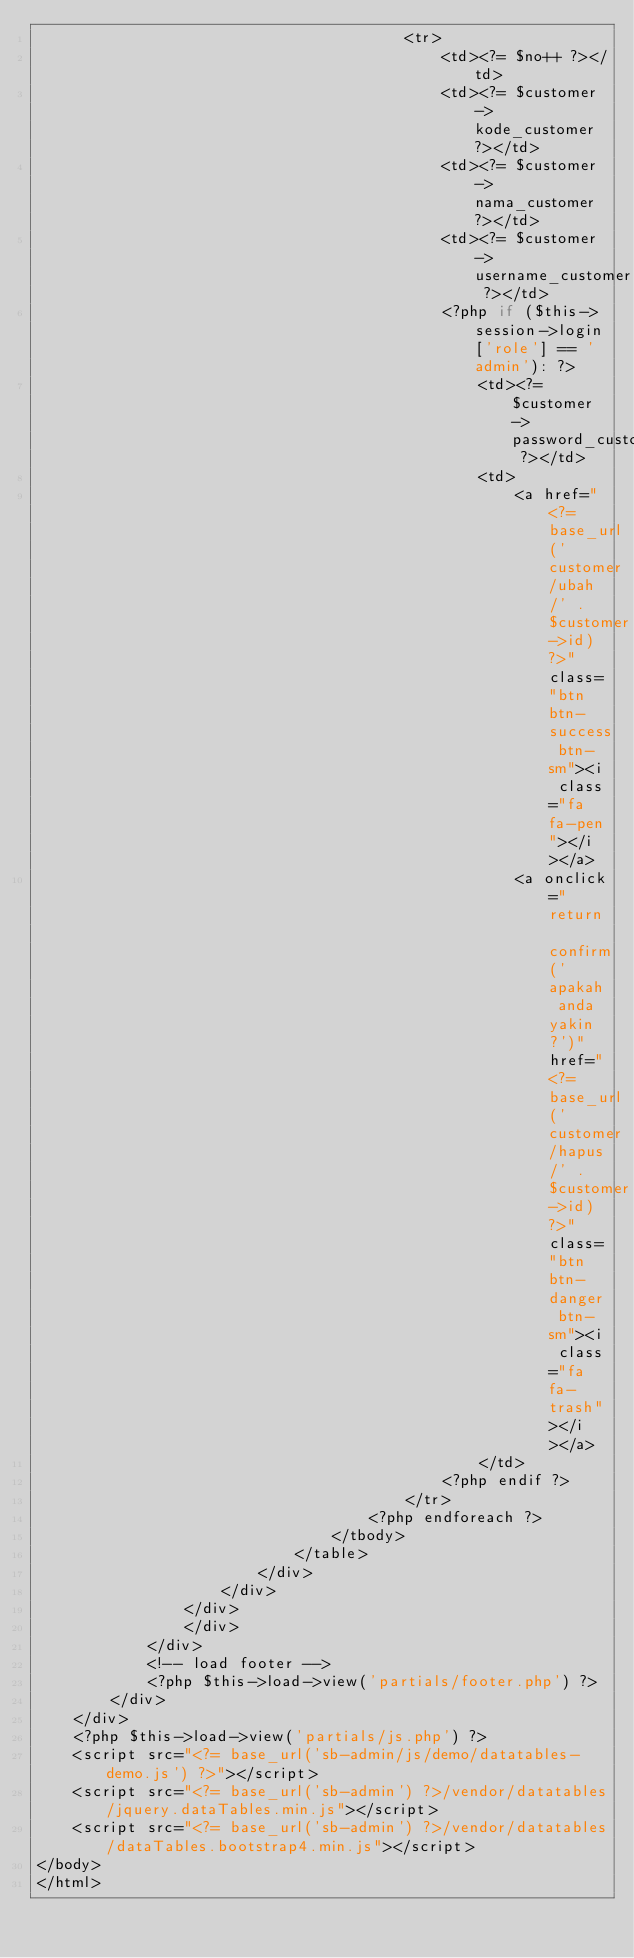<code> <loc_0><loc_0><loc_500><loc_500><_PHP_>										<tr>
											<td><?= $no++ ?></td>
											<td><?= $customer->kode_customer ?></td>
											<td><?= $customer->nama_customer ?></td>
											<td><?= $customer->username_customer ?></td>
											<?php if ($this->session->login['role'] == 'admin'): ?>
												<td><?= $customer->password_customer ?></td>
												<td>
													<a href="<?= base_url('customer/ubah/' . $customer->id) ?>" class="btn btn-success btn-sm"><i class="fa fa-pen"></i></a>
													<a onclick="return confirm('apakah anda yakin?')" href="<?= base_url('customer/hapus/' . $customer->id) ?>" class="btn btn-danger btn-sm"><i class="fa fa-trash"></i></a>
												</td>	
											<?php endif ?>
										</tr>
									<?php endforeach ?>
								</tbody>
							</table>
						</div>
					</div>				
				</div>
				</div>
			</div>
			<!-- load footer -->
			<?php $this->load->view('partials/footer.php') ?>
		</div>
	</div>
	<?php $this->load->view('partials/js.php') ?>
	<script src="<?= base_url('sb-admin/js/demo/datatables-demo.js') ?>"></script>
	<script src="<?= base_url('sb-admin') ?>/vendor/datatables/jquery.dataTables.min.js"></script>
	<script src="<?= base_url('sb-admin') ?>/vendor/datatables/dataTables.bootstrap4.min.js"></script>
</body>
</html></code> 